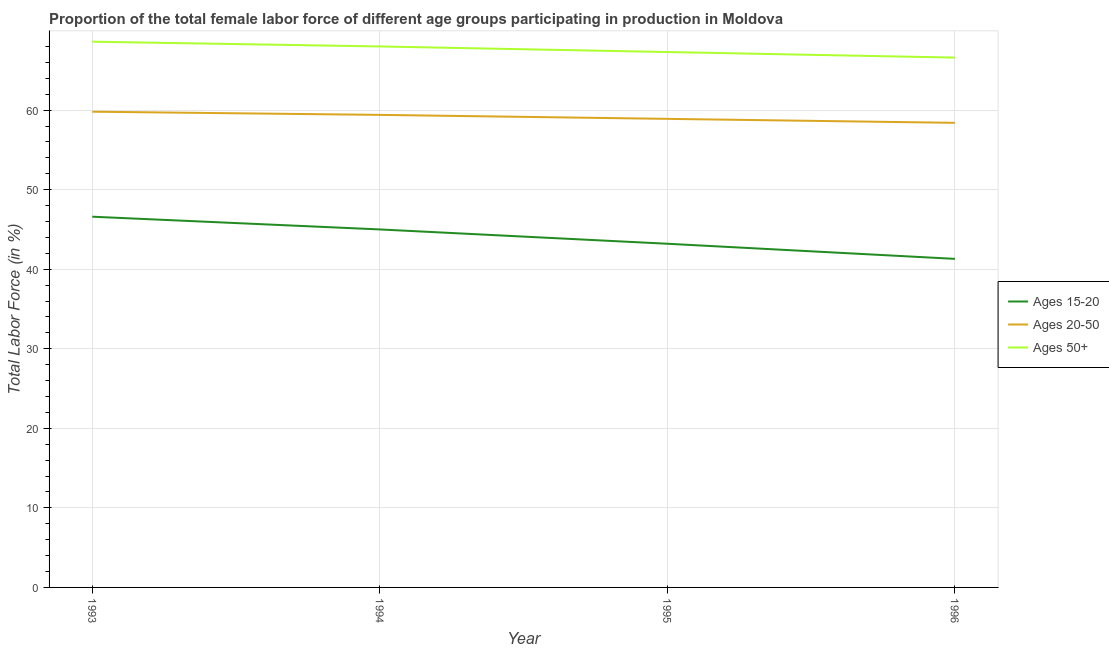Does the line corresponding to percentage of female labor force within the age group 20-50 intersect with the line corresponding to percentage of female labor force within the age group 15-20?
Offer a terse response. No. What is the percentage of female labor force within the age group 15-20 in 1996?
Your response must be concise. 41.3. Across all years, what is the maximum percentage of female labor force within the age group 15-20?
Your answer should be very brief. 46.6. Across all years, what is the minimum percentage of female labor force within the age group 20-50?
Give a very brief answer. 58.4. In which year was the percentage of female labor force above age 50 maximum?
Your answer should be very brief. 1993. In which year was the percentage of female labor force within the age group 15-20 minimum?
Offer a very short reply. 1996. What is the total percentage of female labor force within the age group 15-20 in the graph?
Your answer should be compact. 176.1. What is the difference between the percentage of female labor force within the age group 15-20 in 1994 and that in 1995?
Your response must be concise. 1.8. What is the difference between the percentage of female labor force within the age group 20-50 in 1994 and the percentage of female labor force within the age group 15-20 in 1993?
Provide a short and direct response. 12.8. What is the average percentage of female labor force above age 50 per year?
Your answer should be compact. 67.62. In the year 1996, what is the difference between the percentage of female labor force above age 50 and percentage of female labor force within the age group 15-20?
Your response must be concise. 25.3. In how many years, is the percentage of female labor force within the age group 20-50 greater than 8 %?
Give a very brief answer. 4. What is the ratio of the percentage of female labor force above age 50 in 1993 to that in 1996?
Offer a terse response. 1.03. What is the difference between the highest and the second highest percentage of female labor force within the age group 20-50?
Keep it short and to the point. 0.4. What is the difference between the highest and the lowest percentage of female labor force within the age group 20-50?
Your response must be concise. 1.4. In how many years, is the percentage of female labor force within the age group 20-50 greater than the average percentage of female labor force within the age group 20-50 taken over all years?
Offer a terse response. 2. How many lines are there?
Offer a very short reply. 3. How many years are there in the graph?
Your response must be concise. 4. What is the difference between two consecutive major ticks on the Y-axis?
Your answer should be compact. 10. Are the values on the major ticks of Y-axis written in scientific E-notation?
Offer a very short reply. No. Does the graph contain grids?
Offer a terse response. Yes. Where does the legend appear in the graph?
Your response must be concise. Center right. What is the title of the graph?
Provide a succinct answer. Proportion of the total female labor force of different age groups participating in production in Moldova. What is the label or title of the X-axis?
Offer a very short reply. Year. What is the Total Labor Force (in %) of Ages 15-20 in 1993?
Your answer should be compact. 46.6. What is the Total Labor Force (in %) of Ages 20-50 in 1993?
Provide a succinct answer. 59.8. What is the Total Labor Force (in %) in Ages 50+ in 1993?
Your answer should be very brief. 68.6. What is the Total Labor Force (in %) of Ages 15-20 in 1994?
Offer a very short reply. 45. What is the Total Labor Force (in %) of Ages 20-50 in 1994?
Make the answer very short. 59.4. What is the Total Labor Force (in %) of Ages 50+ in 1994?
Your response must be concise. 68. What is the Total Labor Force (in %) of Ages 15-20 in 1995?
Keep it short and to the point. 43.2. What is the Total Labor Force (in %) of Ages 20-50 in 1995?
Your answer should be very brief. 58.9. What is the Total Labor Force (in %) in Ages 50+ in 1995?
Keep it short and to the point. 67.3. What is the Total Labor Force (in %) of Ages 15-20 in 1996?
Your answer should be very brief. 41.3. What is the Total Labor Force (in %) in Ages 20-50 in 1996?
Give a very brief answer. 58.4. What is the Total Labor Force (in %) in Ages 50+ in 1996?
Your answer should be compact. 66.6. Across all years, what is the maximum Total Labor Force (in %) in Ages 15-20?
Your response must be concise. 46.6. Across all years, what is the maximum Total Labor Force (in %) in Ages 20-50?
Offer a terse response. 59.8. Across all years, what is the maximum Total Labor Force (in %) in Ages 50+?
Give a very brief answer. 68.6. Across all years, what is the minimum Total Labor Force (in %) in Ages 15-20?
Provide a short and direct response. 41.3. Across all years, what is the minimum Total Labor Force (in %) in Ages 20-50?
Offer a very short reply. 58.4. Across all years, what is the minimum Total Labor Force (in %) of Ages 50+?
Your response must be concise. 66.6. What is the total Total Labor Force (in %) of Ages 15-20 in the graph?
Provide a succinct answer. 176.1. What is the total Total Labor Force (in %) in Ages 20-50 in the graph?
Offer a very short reply. 236.5. What is the total Total Labor Force (in %) of Ages 50+ in the graph?
Keep it short and to the point. 270.5. What is the difference between the Total Labor Force (in %) of Ages 15-20 in 1993 and that in 1994?
Your answer should be compact. 1.6. What is the difference between the Total Labor Force (in %) of Ages 20-50 in 1993 and that in 1994?
Your response must be concise. 0.4. What is the difference between the Total Labor Force (in %) of Ages 50+ in 1993 and that in 1994?
Keep it short and to the point. 0.6. What is the difference between the Total Labor Force (in %) of Ages 50+ in 1993 and that in 1995?
Your answer should be compact. 1.3. What is the difference between the Total Labor Force (in %) of Ages 15-20 in 1993 and that in 1996?
Provide a short and direct response. 5.3. What is the difference between the Total Labor Force (in %) of Ages 50+ in 1994 and that in 1996?
Provide a short and direct response. 1.4. What is the difference between the Total Labor Force (in %) in Ages 20-50 in 1995 and that in 1996?
Offer a very short reply. 0.5. What is the difference between the Total Labor Force (in %) in Ages 50+ in 1995 and that in 1996?
Make the answer very short. 0.7. What is the difference between the Total Labor Force (in %) of Ages 15-20 in 1993 and the Total Labor Force (in %) of Ages 50+ in 1994?
Give a very brief answer. -21.4. What is the difference between the Total Labor Force (in %) of Ages 20-50 in 1993 and the Total Labor Force (in %) of Ages 50+ in 1994?
Your response must be concise. -8.2. What is the difference between the Total Labor Force (in %) in Ages 15-20 in 1993 and the Total Labor Force (in %) in Ages 50+ in 1995?
Provide a succinct answer. -20.7. What is the difference between the Total Labor Force (in %) in Ages 20-50 in 1993 and the Total Labor Force (in %) in Ages 50+ in 1996?
Keep it short and to the point. -6.8. What is the difference between the Total Labor Force (in %) of Ages 15-20 in 1994 and the Total Labor Force (in %) of Ages 20-50 in 1995?
Give a very brief answer. -13.9. What is the difference between the Total Labor Force (in %) of Ages 15-20 in 1994 and the Total Labor Force (in %) of Ages 50+ in 1995?
Give a very brief answer. -22.3. What is the difference between the Total Labor Force (in %) of Ages 20-50 in 1994 and the Total Labor Force (in %) of Ages 50+ in 1995?
Your answer should be very brief. -7.9. What is the difference between the Total Labor Force (in %) of Ages 15-20 in 1994 and the Total Labor Force (in %) of Ages 50+ in 1996?
Offer a terse response. -21.6. What is the difference between the Total Labor Force (in %) of Ages 20-50 in 1994 and the Total Labor Force (in %) of Ages 50+ in 1996?
Give a very brief answer. -7.2. What is the difference between the Total Labor Force (in %) in Ages 15-20 in 1995 and the Total Labor Force (in %) in Ages 20-50 in 1996?
Provide a short and direct response. -15.2. What is the difference between the Total Labor Force (in %) of Ages 15-20 in 1995 and the Total Labor Force (in %) of Ages 50+ in 1996?
Make the answer very short. -23.4. What is the difference between the Total Labor Force (in %) of Ages 20-50 in 1995 and the Total Labor Force (in %) of Ages 50+ in 1996?
Your response must be concise. -7.7. What is the average Total Labor Force (in %) in Ages 15-20 per year?
Offer a terse response. 44.02. What is the average Total Labor Force (in %) of Ages 20-50 per year?
Give a very brief answer. 59.12. What is the average Total Labor Force (in %) in Ages 50+ per year?
Keep it short and to the point. 67.62. In the year 1993, what is the difference between the Total Labor Force (in %) of Ages 15-20 and Total Labor Force (in %) of Ages 20-50?
Provide a short and direct response. -13.2. In the year 1994, what is the difference between the Total Labor Force (in %) of Ages 15-20 and Total Labor Force (in %) of Ages 20-50?
Provide a short and direct response. -14.4. In the year 1995, what is the difference between the Total Labor Force (in %) of Ages 15-20 and Total Labor Force (in %) of Ages 20-50?
Offer a terse response. -15.7. In the year 1995, what is the difference between the Total Labor Force (in %) of Ages 15-20 and Total Labor Force (in %) of Ages 50+?
Provide a short and direct response. -24.1. In the year 1995, what is the difference between the Total Labor Force (in %) in Ages 20-50 and Total Labor Force (in %) in Ages 50+?
Make the answer very short. -8.4. In the year 1996, what is the difference between the Total Labor Force (in %) in Ages 15-20 and Total Labor Force (in %) in Ages 20-50?
Give a very brief answer. -17.1. In the year 1996, what is the difference between the Total Labor Force (in %) in Ages 15-20 and Total Labor Force (in %) in Ages 50+?
Offer a terse response. -25.3. In the year 1996, what is the difference between the Total Labor Force (in %) of Ages 20-50 and Total Labor Force (in %) of Ages 50+?
Keep it short and to the point. -8.2. What is the ratio of the Total Labor Force (in %) of Ages 15-20 in 1993 to that in 1994?
Provide a succinct answer. 1.04. What is the ratio of the Total Labor Force (in %) of Ages 20-50 in 1993 to that in 1994?
Offer a terse response. 1.01. What is the ratio of the Total Labor Force (in %) in Ages 50+ in 1993 to that in 1994?
Offer a terse response. 1.01. What is the ratio of the Total Labor Force (in %) in Ages 15-20 in 1993 to that in 1995?
Your answer should be compact. 1.08. What is the ratio of the Total Labor Force (in %) in Ages 20-50 in 1993 to that in 1995?
Your answer should be compact. 1.02. What is the ratio of the Total Labor Force (in %) of Ages 50+ in 1993 to that in 1995?
Ensure brevity in your answer.  1.02. What is the ratio of the Total Labor Force (in %) in Ages 15-20 in 1993 to that in 1996?
Your answer should be very brief. 1.13. What is the ratio of the Total Labor Force (in %) in Ages 15-20 in 1994 to that in 1995?
Offer a very short reply. 1.04. What is the ratio of the Total Labor Force (in %) of Ages 20-50 in 1994 to that in 1995?
Your response must be concise. 1.01. What is the ratio of the Total Labor Force (in %) of Ages 50+ in 1994 to that in 1995?
Provide a short and direct response. 1.01. What is the ratio of the Total Labor Force (in %) in Ages 15-20 in 1994 to that in 1996?
Your answer should be compact. 1.09. What is the ratio of the Total Labor Force (in %) in Ages 20-50 in 1994 to that in 1996?
Make the answer very short. 1.02. What is the ratio of the Total Labor Force (in %) in Ages 50+ in 1994 to that in 1996?
Ensure brevity in your answer.  1.02. What is the ratio of the Total Labor Force (in %) of Ages 15-20 in 1995 to that in 1996?
Ensure brevity in your answer.  1.05. What is the ratio of the Total Labor Force (in %) in Ages 20-50 in 1995 to that in 1996?
Your answer should be very brief. 1.01. What is the ratio of the Total Labor Force (in %) of Ages 50+ in 1995 to that in 1996?
Keep it short and to the point. 1.01. What is the difference between the highest and the second highest Total Labor Force (in %) in Ages 15-20?
Your answer should be compact. 1.6. What is the difference between the highest and the second highest Total Labor Force (in %) of Ages 50+?
Provide a succinct answer. 0.6. What is the difference between the highest and the lowest Total Labor Force (in %) of Ages 15-20?
Offer a very short reply. 5.3. What is the difference between the highest and the lowest Total Labor Force (in %) in Ages 20-50?
Provide a short and direct response. 1.4. 